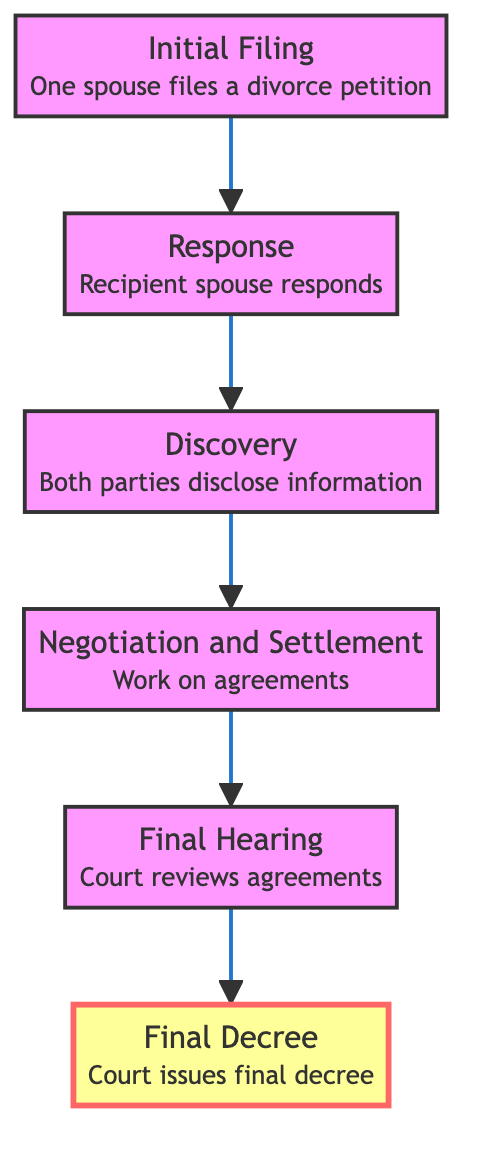What is the first step in the process? The first step in the diagram is labeled "Initial Filing," where one spouse files a divorce petition with the court. It is the bottom node of the flow chart, marking the start of the legal divorce process.
Answer: Initial Filing How many total steps are there in this process? Counting the nodes in the diagram, there are six distinct steps: Initial Filing, Response, Discovery, Negotiation and Settlement, Final Hearing, and Final Decree. This total is confirmed by reviewing each node shown.
Answer: 6 What happens after the Response step? Following the "Response" step, the next step indicated in the flow chart is "Discovery." This shows the sequential relationship where the recipient spouse’s response leads into the discovery process regarding financial disclosure and information sharing.
Answer: Discovery Which step leads to the Final Decree? The "Final Hearing" step leads directly to the "Final Decree." This relationship indicates that after the hearing where agreements are reviewed, the court issues the final decree to legally end the marriage.
Answer: Final Hearing What is involved in the Discovery step? The "Discovery" step involves the process where both parties disclose financial information and assets. This step is crucial for the negotiation that follows, and it’s described in detail within the node itself.
Answer: Financial information disclosure What is the relationship between Negotiation and Settlement and Final Hearing? The relationship is sequential; "Negotiation and Settlement" comes before "Final Hearing." This indicates that agreements must be negotiated and settled before the court can review them during the final hearing.
Answer: Sequential relationship What is the purpose of the Final Hearing step? The purpose of the "Final Hearing" step is for the court to review all agreements made during the negotiation and settlement phase and make the final decision regarding the divorce. This is indicated clearly in the description within the node.
Answer: Review agreements Which step formally starts the legal process? The "Initial Filing" step formally starts the legal process, as indicated in its description where one spouse files a divorce petition with the court. This marks the beginning of the entire divorce proceedings.
Answer: Initial Filing 